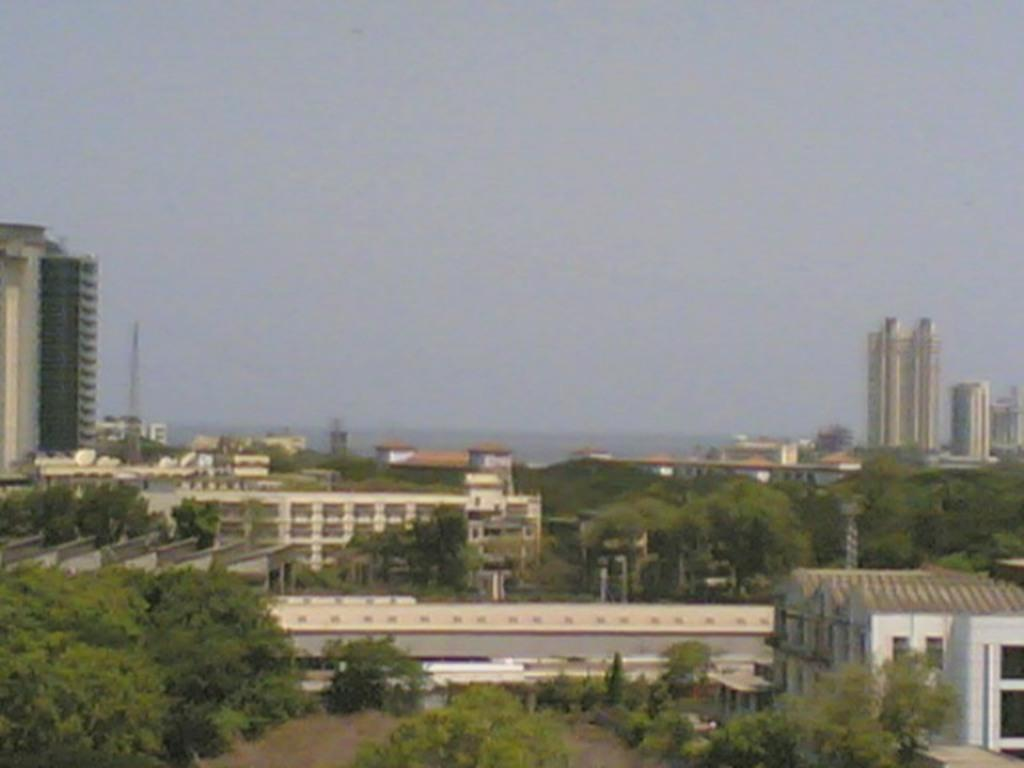What type of vegetation can be seen in the image? There are trees in the image. What structures are present in the image? There are buildings in the image. What is visible at the top of the image? The sky is visible at the top of the image. What type of yard is visible in the image? There is no yard present in the image; it features trees and buildings. What question is being asked in the image? There is no question present in the image; it is a visual representation of trees, buildings, and the sky. 